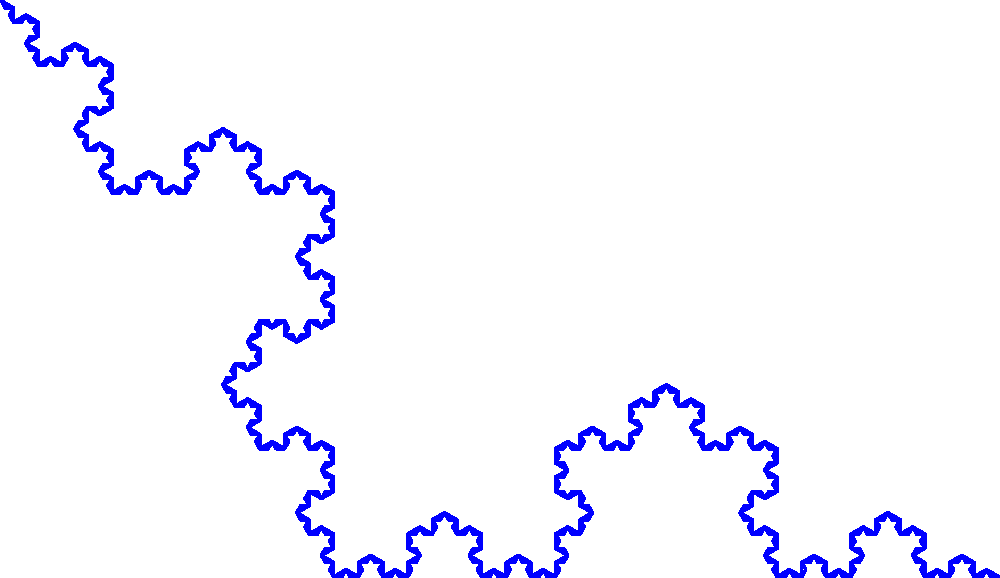In the Koch snowflake shown above, if we start with an equilateral triangle with side length 1, what is the perimeter of the snowflake after 4 iterations? Let's approach this step-by-step:

1) We start with an equilateral triangle of side length 1.
   Initial perimeter = $3$

2) In each iteration, each line segment is replaced by 4 segments, each 1/3 the length of the original.
   This means that after each iteration, the perimeter is multiplied by $4/3$.

3) We can express this mathematically:
   Perimeter after n iterations = $3 * (4/3)^n$

4) We're asked about the 4th iteration, so n = 4:
   Perimeter = $3 * (4/3)^4$

5) Let's calculate this:
   $3 * (4/3)^4 = 3 * (256/81) = 256/27 \approx 9.4815$

Therefore, after 4 iterations, the perimeter of the Koch snowflake is $256/27$ units.
Answer: $\frac{256}{27}$ 